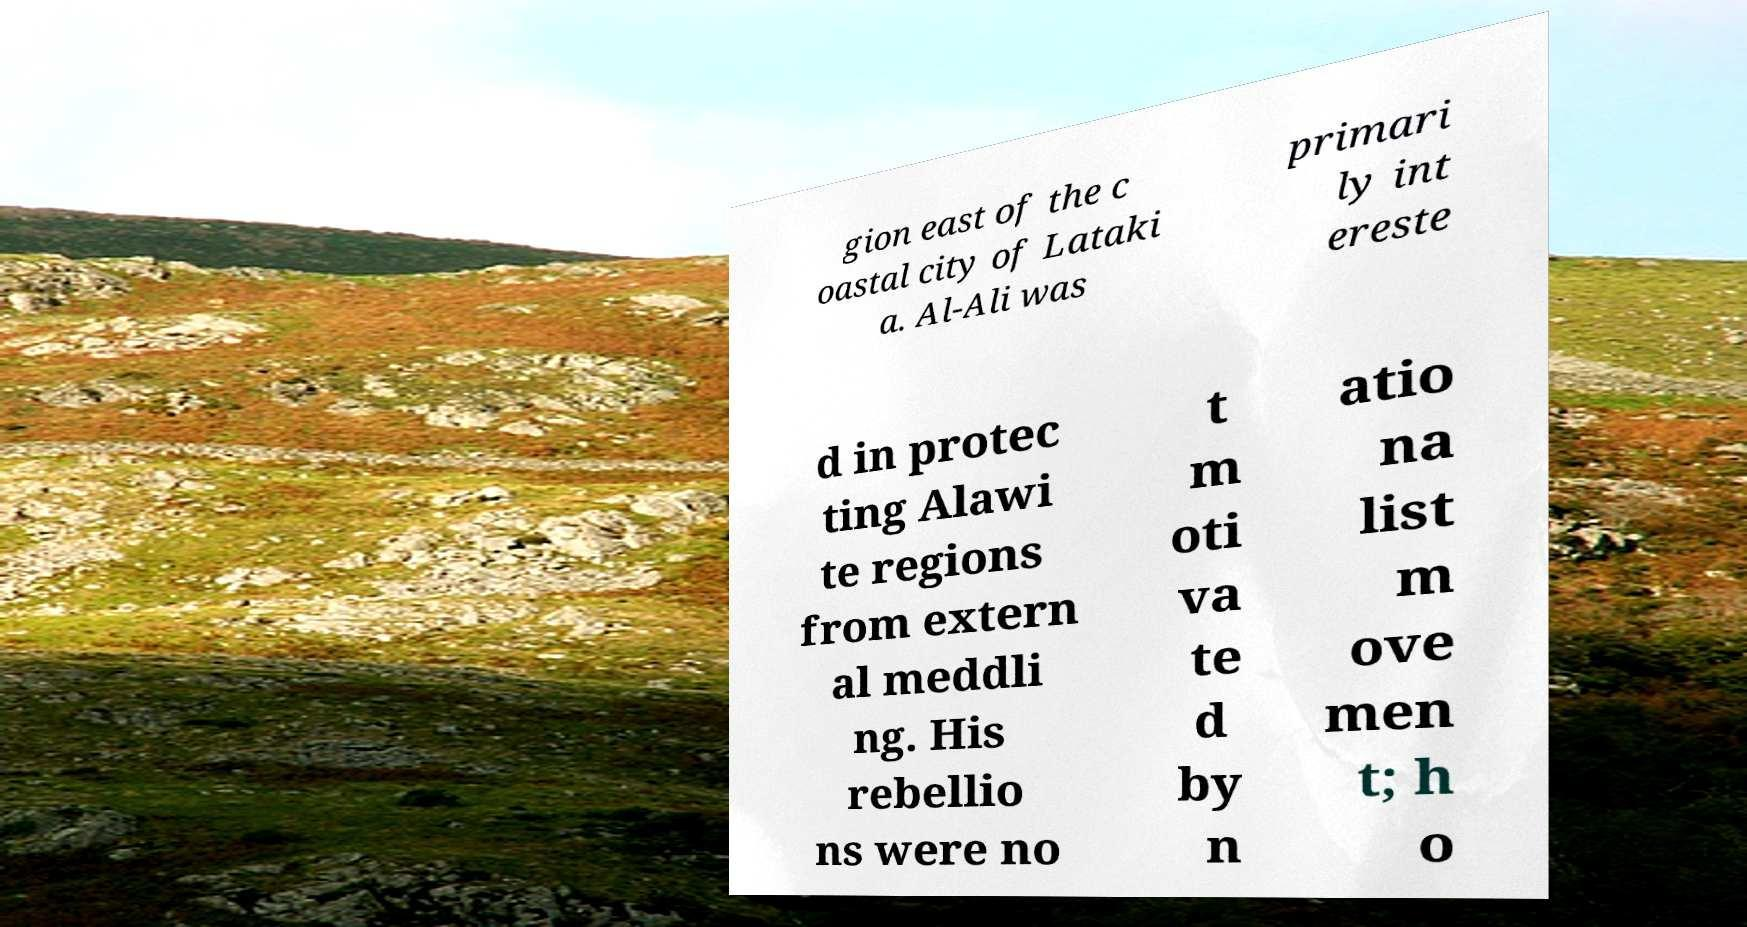Please identify and transcribe the text found in this image. gion east of the c oastal city of Lataki a. Al-Ali was primari ly int ereste d in protec ting Alawi te regions from extern al meddli ng. His rebellio ns were no t m oti va te d by n atio na list m ove men t; h o 